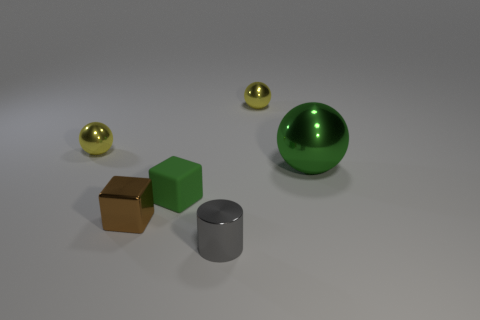Do the large ball and the small matte cube have the same color?
Your answer should be very brief. Yes. What is the size of the shiny object that is the same color as the rubber thing?
Keep it short and to the point. Large. The green sphere that is the same material as the brown block is what size?
Provide a succinct answer. Large. There is a small object that is in front of the cube on the left side of the small green rubber block; how many matte things are in front of it?
Offer a terse response. 0. There is a big metallic thing; is its color the same as the small matte object on the right side of the small brown block?
Your answer should be very brief. Yes. There is a large shiny object that is the same color as the matte thing; what shape is it?
Keep it short and to the point. Sphere. The green object that is on the right side of the tiny yellow shiny object behind the metallic sphere that is left of the small matte cube is made of what material?
Offer a terse response. Metal. There is a green thing that is in front of the green metallic object; is it the same shape as the gray metallic thing?
Offer a very short reply. No. What is the material of the tiny yellow sphere on the right side of the tiny green matte object?
Your answer should be very brief. Metal. What number of metal objects are either small green cubes or tiny brown things?
Your answer should be very brief. 1. 